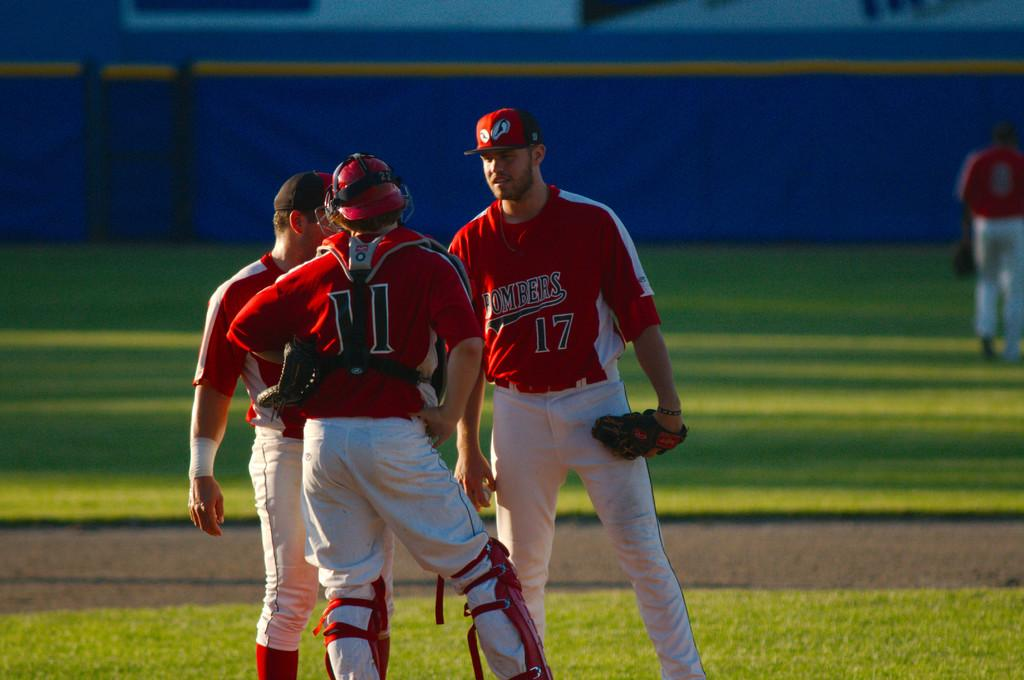<image>
Summarize the visual content of the image. A baseball player has the number 11 on the back of his shirt. 